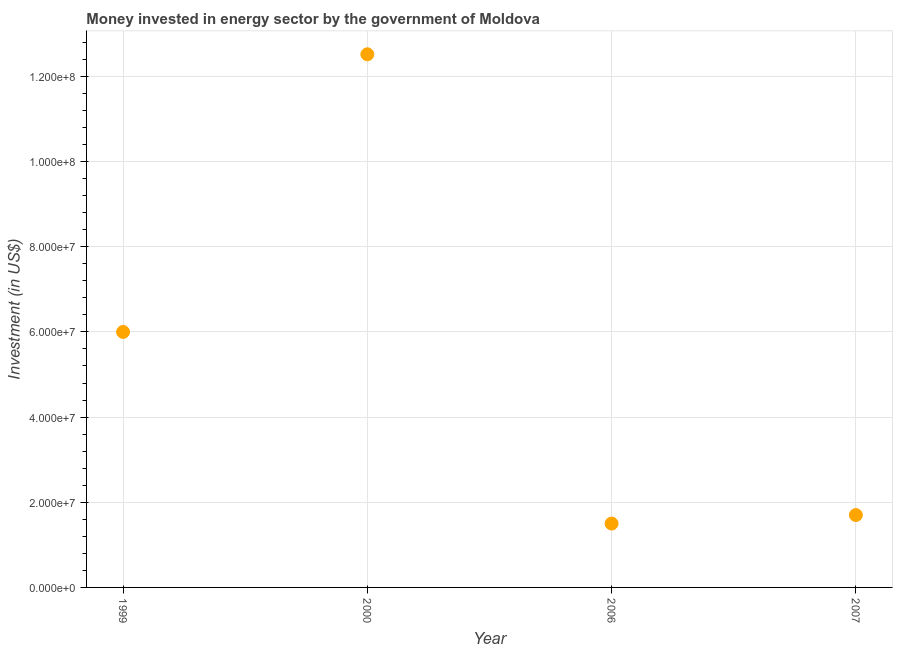What is the investment in energy in 2006?
Give a very brief answer. 1.50e+07. Across all years, what is the maximum investment in energy?
Offer a very short reply. 1.25e+08. Across all years, what is the minimum investment in energy?
Give a very brief answer. 1.50e+07. In which year was the investment in energy maximum?
Ensure brevity in your answer.  2000. What is the sum of the investment in energy?
Provide a short and direct response. 2.17e+08. What is the difference between the investment in energy in 2000 and 2006?
Provide a short and direct response. 1.10e+08. What is the average investment in energy per year?
Your answer should be very brief. 5.43e+07. What is the median investment in energy?
Your answer should be very brief. 3.85e+07. What is the ratio of the investment in energy in 2000 to that in 2006?
Keep it short and to the point. 8.35. What is the difference between the highest and the second highest investment in energy?
Offer a terse response. 6.52e+07. What is the difference between the highest and the lowest investment in energy?
Your response must be concise. 1.10e+08. Does the investment in energy monotonically increase over the years?
Ensure brevity in your answer.  No. Are the values on the major ticks of Y-axis written in scientific E-notation?
Your answer should be compact. Yes. Does the graph contain any zero values?
Give a very brief answer. No. What is the title of the graph?
Your answer should be very brief. Money invested in energy sector by the government of Moldova. What is the label or title of the Y-axis?
Ensure brevity in your answer.  Investment (in US$). What is the Investment (in US$) in 1999?
Offer a very short reply. 6.00e+07. What is the Investment (in US$) in 2000?
Your answer should be very brief. 1.25e+08. What is the Investment (in US$) in 2006?
Your answer should be compact. 1.50e+07. What is the Investment (in US$) in 2007?
Ensure brevity in your answer.  1.70e+07. What is the difference between the Investment (in US$) in 1999 and 2000?
Keep it short and to the point. -6.52e+07. What is the difference between the Investment (in US$) in 1999 and 2006?
Your response must be concise. 4.50e+07. What is the difference between the Investment (in US$) in 1999 and 2007?
Make the answer very short. 4.30e+07. What is the difference between the Investment (in US$) in 2000 and 2006?
Provide a succinct answer. 1.10e+08. What is the difference between the Investment (in US$) in 2000 and 2007?
Your answer should be very brief. 1.08e+08. What is the ratio of the Investment (in US$) in 1999 to that in 2000?
Provide a short and direct response. 0.48. What is the ratio of the Investment (in US$) in 1999 to that in 2007?
Your answer should be very brief. 3.53. What is the ratio of the Investment (in US$) in 2000 to that in 2006?
Your answer should be compact. 8.35. What is the ratio of the Investment (in US$) in 2000 to that in 2007?
Your answer should be very brief. 7.37. What is the ratio of the Investment (in US$) in 2006 to that in 2007?
Your response must be concise. 0.88. 